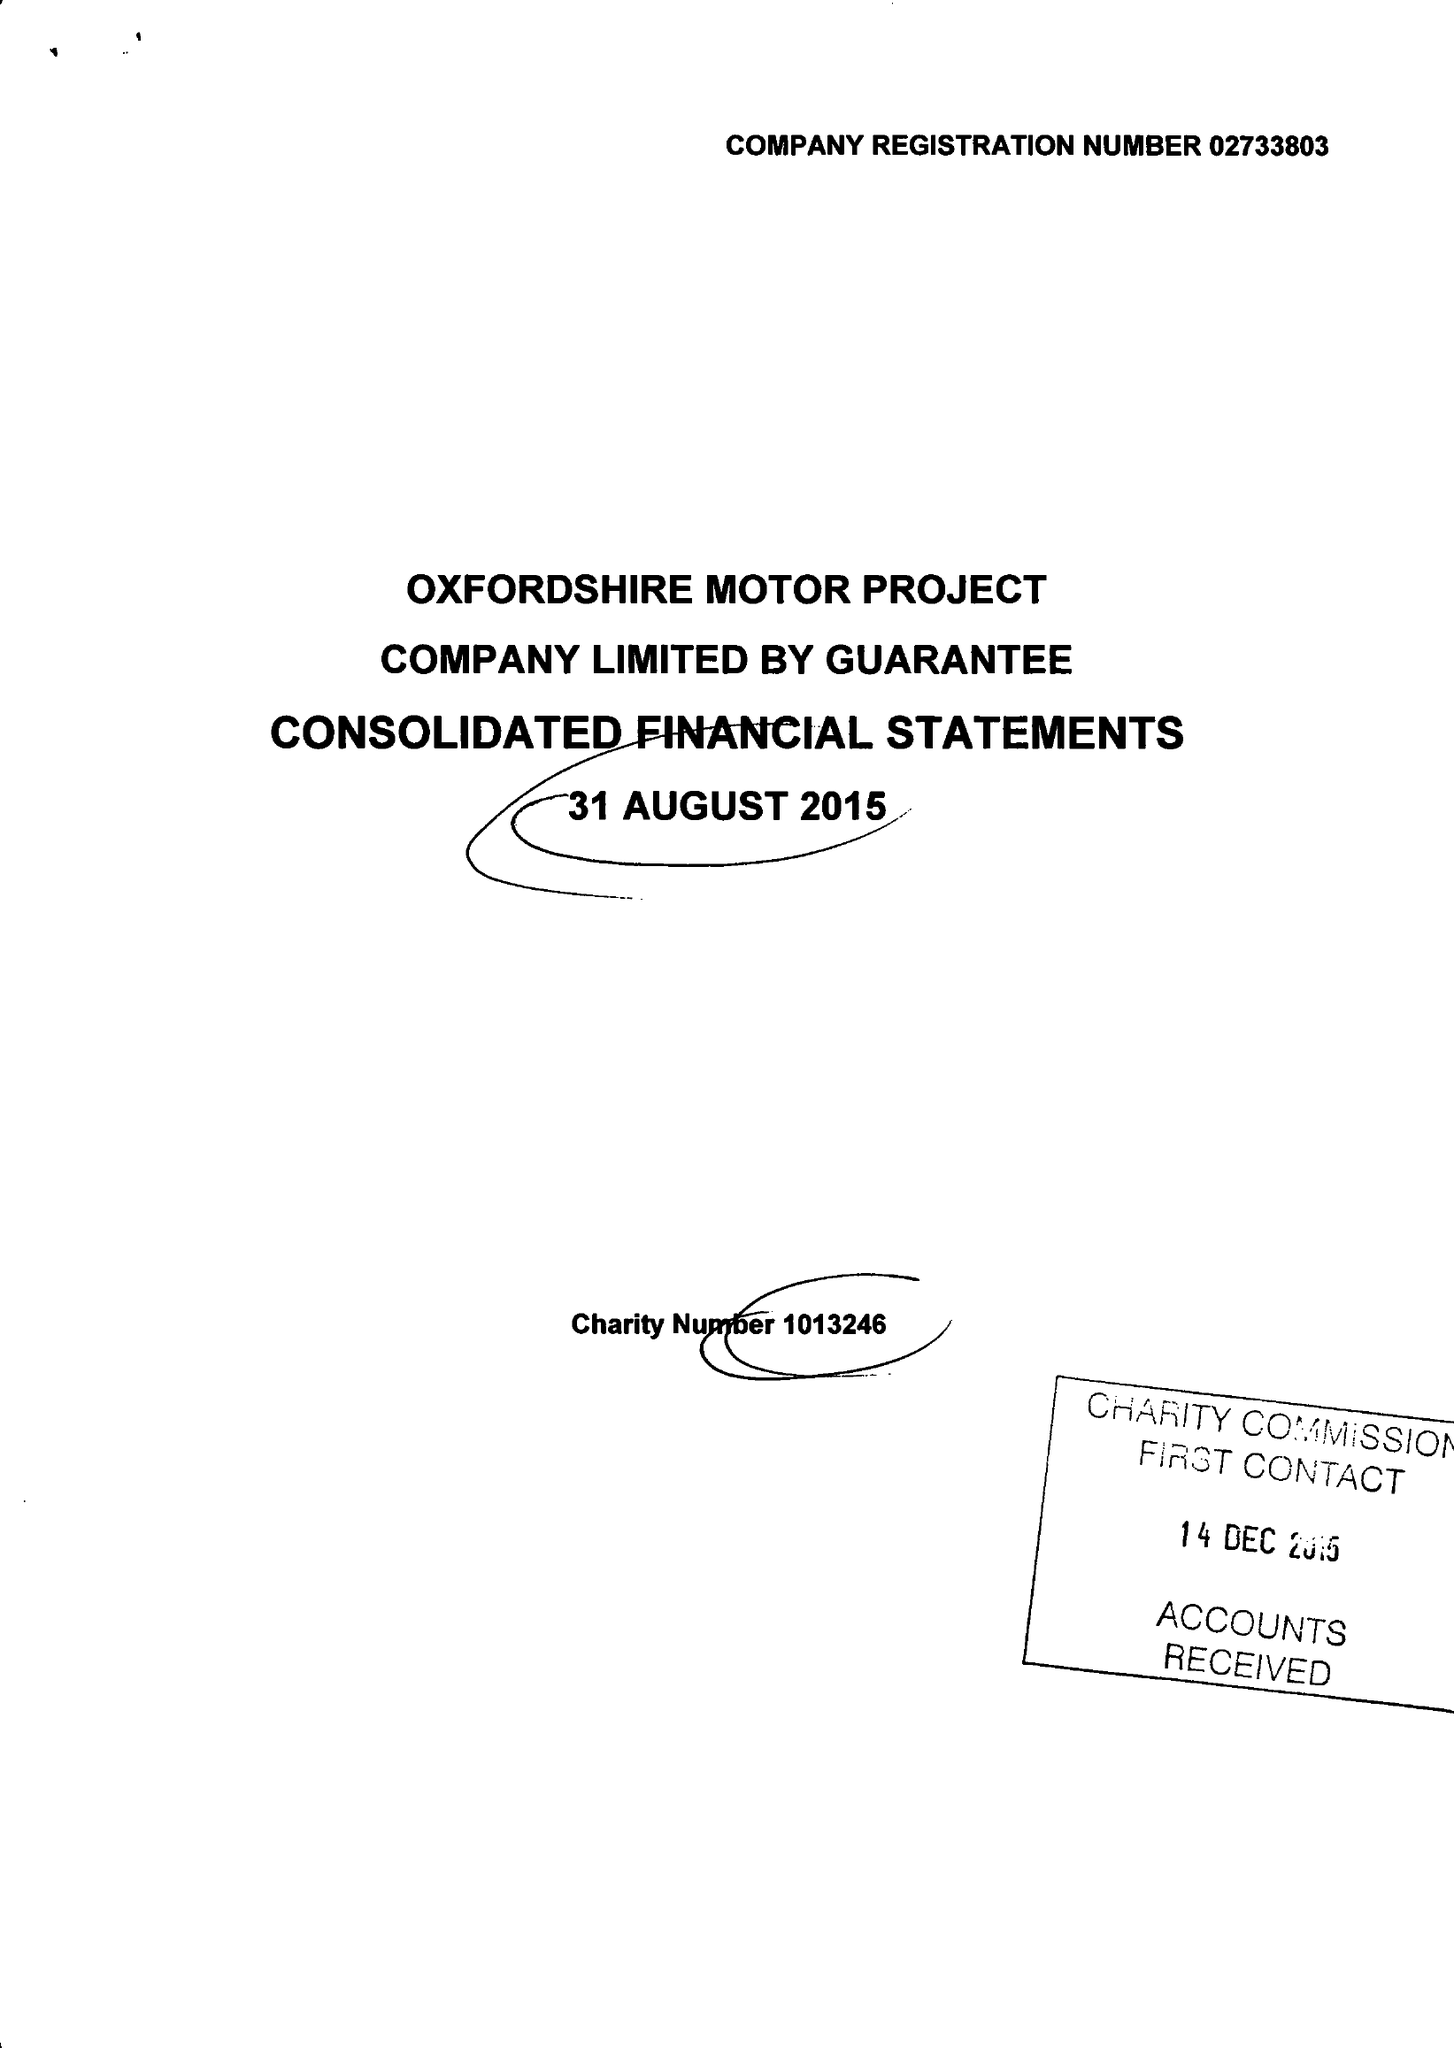What is the value for the address__post_town?
Answer the question using a single word or phrase. OXFORD 